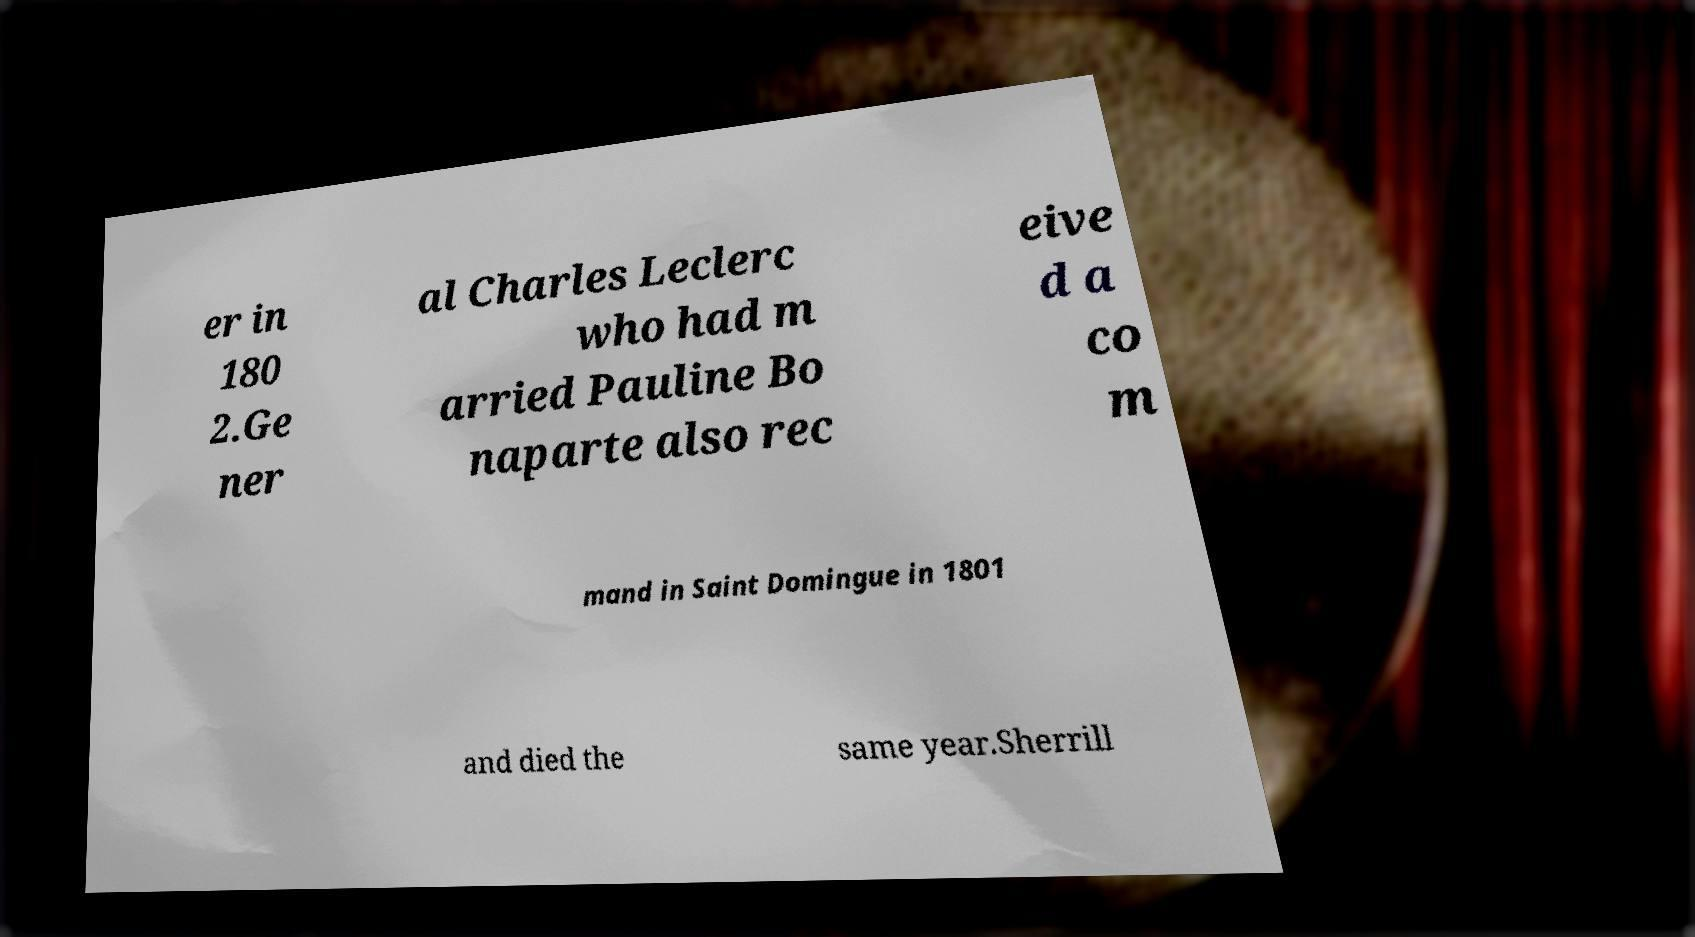Could you extract and type out the text from this image? er in 180 2.Ge ner al Charles Leclerc who had m arried Pauline Bo naparte also rec eive d a co m mand in Saint Domingue in 1801 and died the same year.Sherrill 